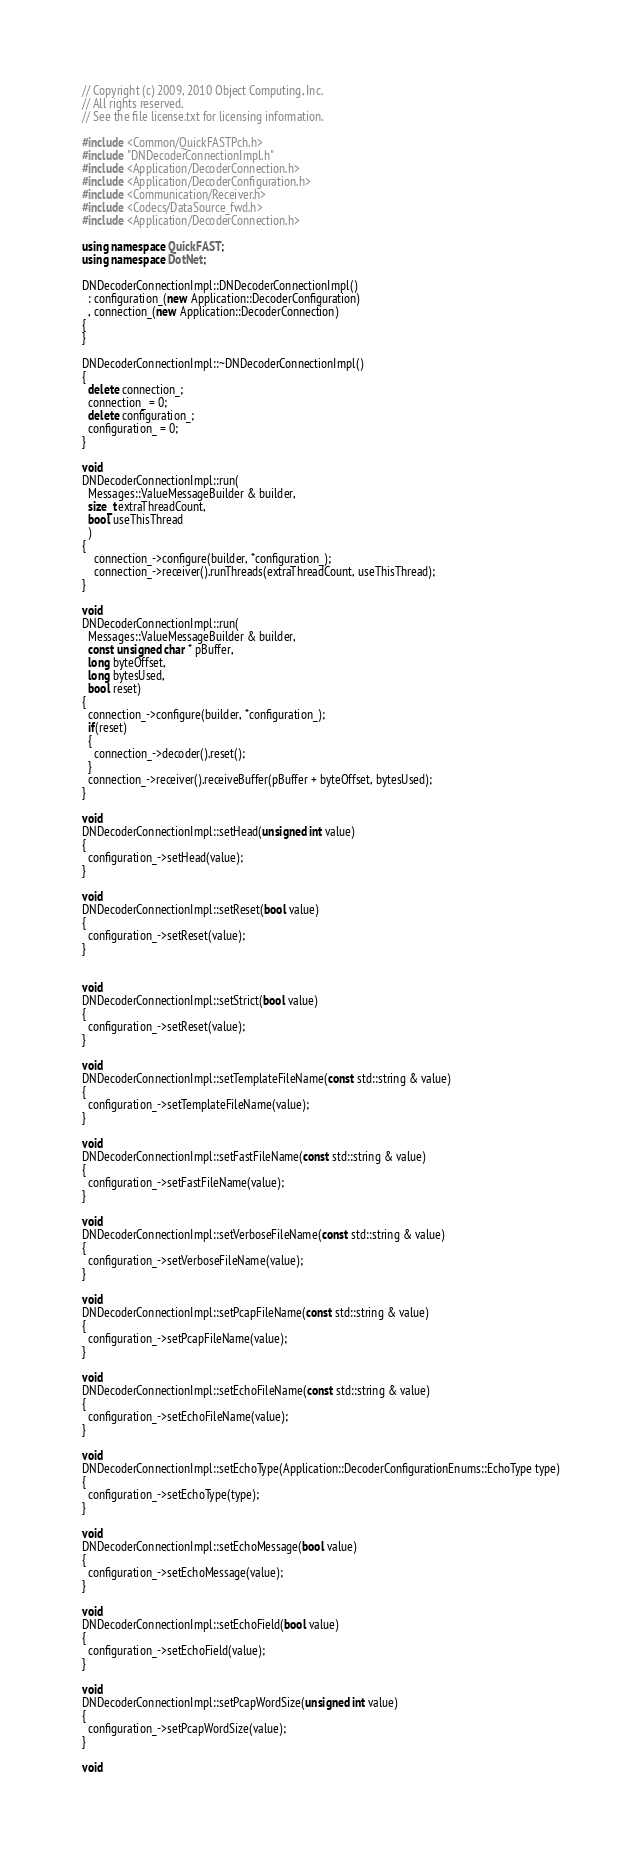<code> <loc_0><loc_0><loc_500><loc_500><_C++_>// Copyright (c) 2009, 2010 Object Computing, Inc.
// All rights reserved.
// See the file license.txt for licensing information.

#include <Common/QuickFASTPch.h>
#include "DNDecoderConnectionImpl.h"
#include <Application/DecoderConnection.h>
#include <Application/DecoderConfiguration.h>
#include <Communication/Receiver.h>
#include <Codecs/DataSource_fwd.h>
#include <Application/DecoderConnection.h>

using namespace QuickFAST;
using namespace DotNet;

DNDecoderConnectionImpl::DNDecoderConnectionImpl()
  : configuration_(new Application::DecoderConfiguration)
  , connection_(new Application::DecoderConnection)
{
}

DNDecoderConnectionImpl::~DNDecoderConnectionImpl()
{
  delete connection_;
  connection_ = 0;
  delete configuration_;
  configuration_ = 0;
}

void
DNDecoderConnectionImpl::run(
  Messages::ValueMessageBuilder & builder,
  size_t extraThreadCount,
  bool useThisThread
  )
{
    connection_->configure(builder, *configuration_);
    connection_->receiver().runThreads(extraThreadCount, useThisThread);
}

void
DNDecoderConnectionImpl::run(
  Messages::ValueMessageBuilder & builder,
  const unsigned char * pBuffer,
  long byteOffset,
  long bytesUsed,
  bool reset)
{
  connection_->configure(builder, *configuration_);
  if(reset)
  {
    connection_->decoder().reset();
  }
  connection_->receiver().receiveBuffer(pBuffer + byteOffset, bytesUsed);
}

void
DNDecoderConnectionImpl::setHead(unsigned int value)
{
  configuration_->setHead(value);
}

void
DNDecoderConnectionImpl::setReset(bool value)
{
  configuration_->setReset(value);
}


void
DNDecoderConnectionImpl::setStrict(bool value)
{
  configuration_->setReset(value);
}

void
DNDecoderConnectionImpl::setTemplateFileName(const std::string & value)
{
  configuration_->setTemplateFileName(value);
}

void
DNDecoderConnectionImpl::setFastFileName(const std::string & value)
{
  configuration_->setFastFileName(value);
}

void
DNDecoderConnectionImpl::setVerboseFileName(const std::string & value)
{
  configuration_->setVerboseFileName(value);
}

void
DNDecoderConnectionImpl::setPcapFileName(const std::string & value)
{
  configuration_->setPcapFileName(value);
}

void
DNDecoderConnectionImpl::setEchoFileName(const std::string & value)
{
  configuration_->setEchoFileName(value);
}

void
DNDecoderConnectionImpl::setEchoType(Application::DecoderConfigurationEnums::EchoType type)
{
  configuration_->setEchoType(type);
}

void
DNDecoderConnectionImpl::setEchoMessage(bool value)
{
  configuration_->setEchoMessage(value);
}

void
DNDecoderConnectionImpl::setEchoField(bool value)
{
  configuration_->setEchoField(value);
}

void
DNDecoderConnectionImpl::setPcapWordSize(unsigned int value)
{
  configuration_->setPcapWordSize(value);
}

void</code> 